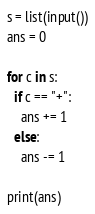Convert code to text. <code><loc_0><loc_0><loc_500><loc_500><_Python_>s = list(input())
ans = 0

for c in s:
  if c == "+":
    ans += 1
  else:
    ans -= 1

print(ans)</code> 